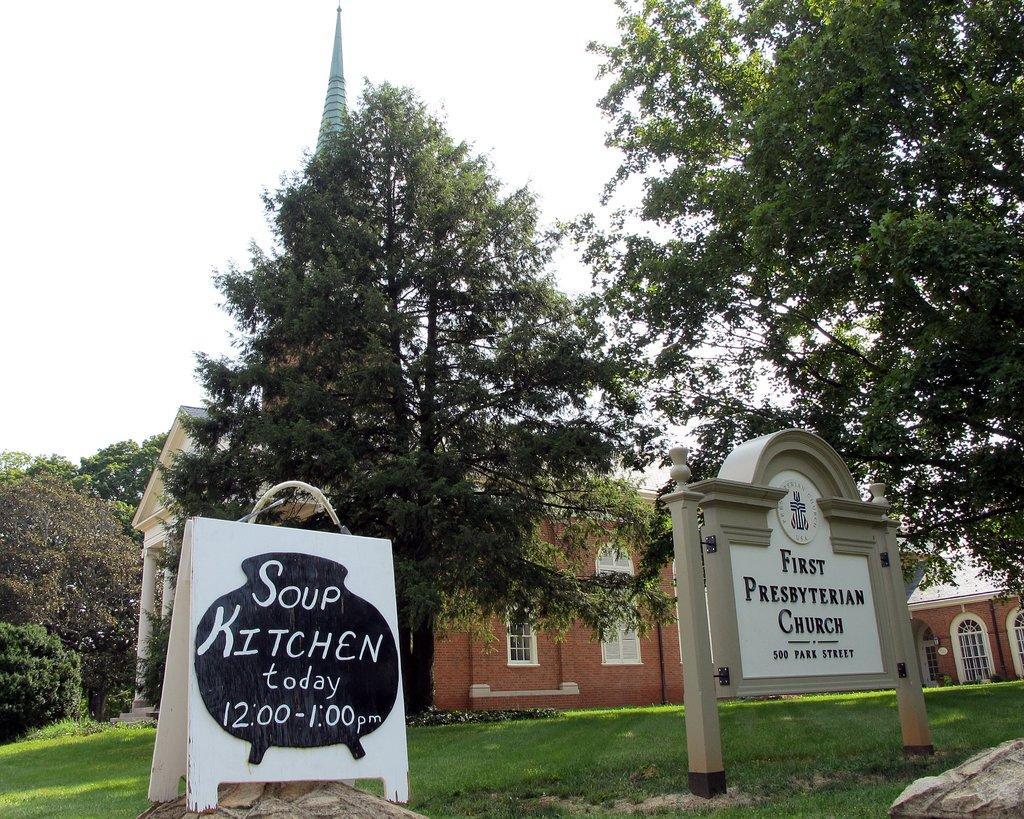In one or two sentences, can you explain what this image depicts? In this picture we can see the grass, rocks, name boards, trees, building with windows and in the background we can see the sky. 